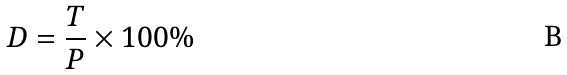<formula> <loc_0><loc_0><loc_500><loc_500>D = \frac { T } { P } \times 1 0 0 \%</formula> 